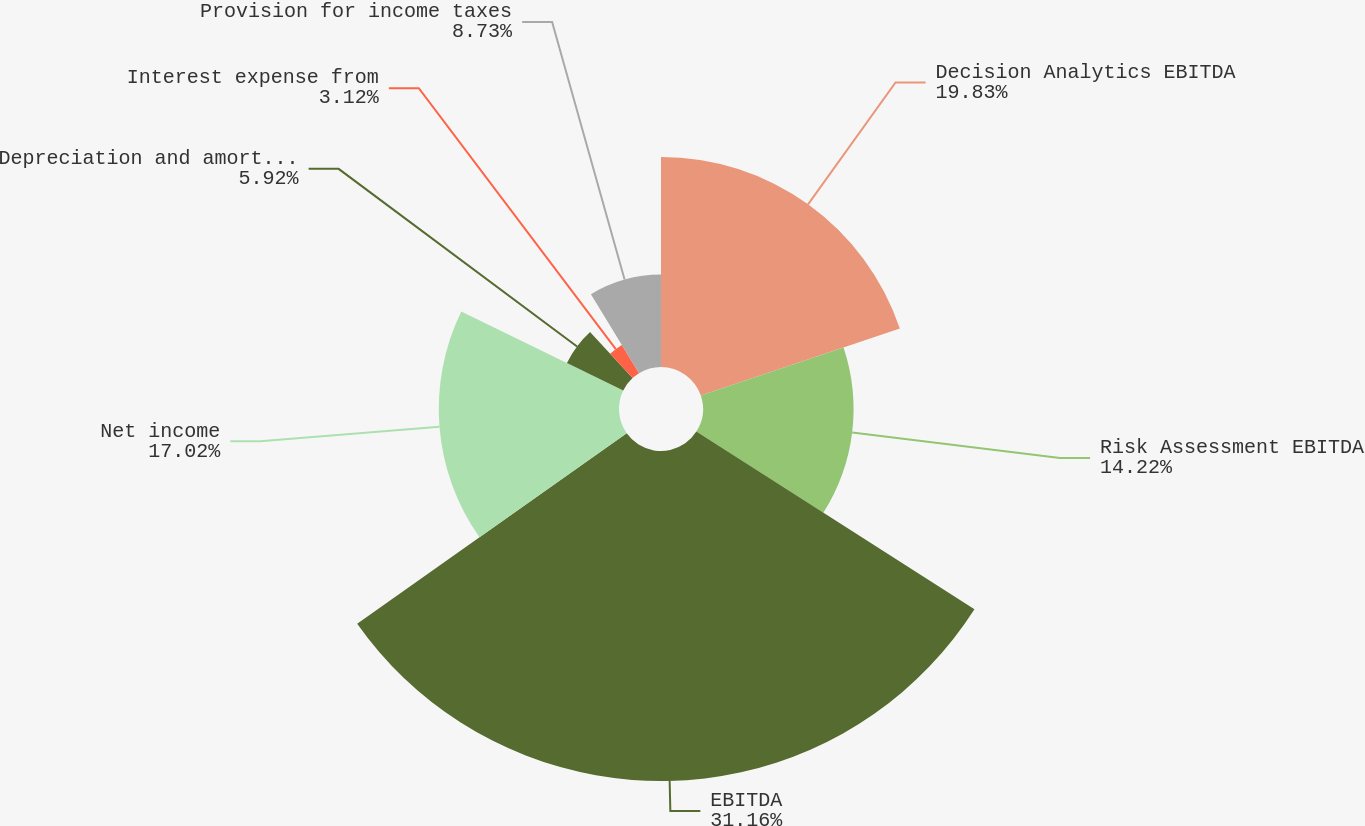Convert chart. <chart><loc_0><loc_0><loc_500><loc_500><pie_chart><fcel>Decision Analytics EBITDA<fcel>Risk Assessment EBITDA<fcel>EBITDA<fcel>Net income<fcel>Depreciation and amortization<fcel>Interest expense from<fcel>Provision for income taxes<nl><fcel>19.83%<fcel>14.22%<fcel>31.16%<fcel>17.02%<fcel>5.92%<fcel>3.12%<fcel>8.73%<nl></chart> 